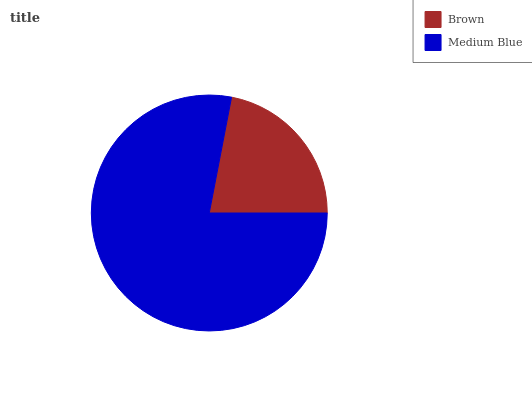Is Brown the minimum?
Answer yes or no. Yes. Is Medium Blue the maximum?
Answer yes or no. Yes. Is Medium Blue the minimum?
Answer yes or no. No. Is Medium Blue greater than Brown?
Answer yes or no. Yes. Is Brown less than Medium Blue?
Answer yes or no. Yes. Is Brown greater than Medium Blue?
Answer yes or no. No. Is Medium Blue less than Brown?
Answer yes or no. No. Is Medium Blue the high median?
Answer yes or no. Yes. Is Brown the low median?
Answer yes or no. Yes. Is Brown the high median?
Answer yes or no. No. Is Medium Blue the low median?
Answer yes or no. No. 